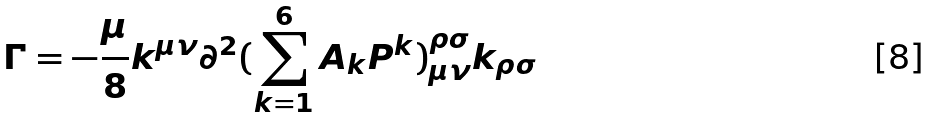<formula> <loc_0><loc_0><loc_500><loc_500>\Gamma = - \frac { \mu } { 8 } k ^ { \mu \nu } \partial ^ { 2 } ( \sum ^ { 6 } _ { k = 1 } A _ { k } P ^ { k } ) ^ { \rho \sigma } _ { \mu \nu } k _ { \rho \sigma }</formula> 